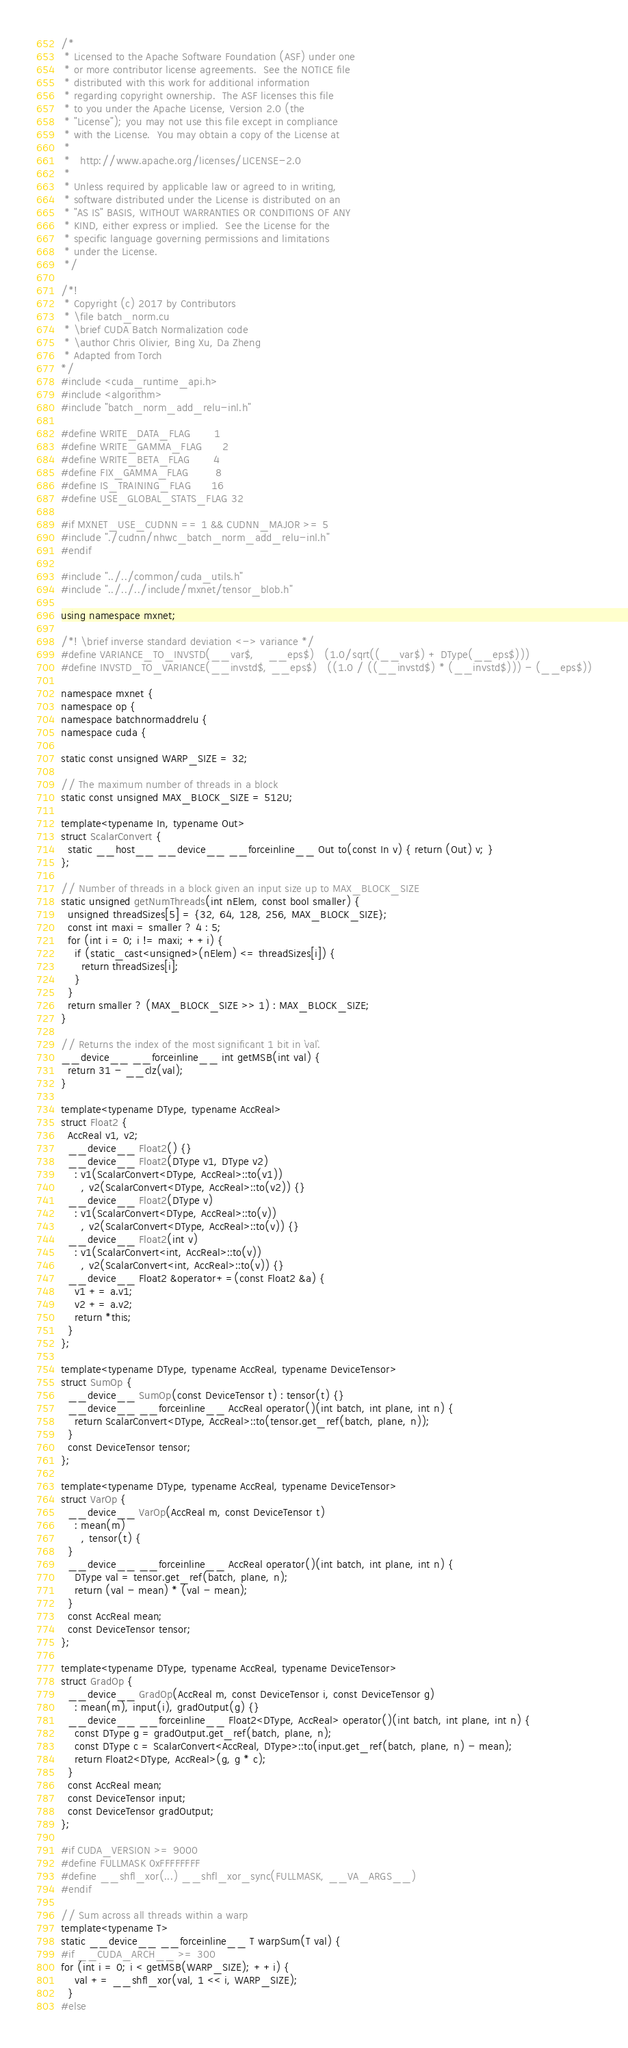<code> <loc_0><loc_0><loc_500><loc_500><_Cuda_>/*
 * Licensed to the Apache Software Foundation (ASF) under one
 * or more contributor license agreements.  See the NOTICE file
 * distributed with this work for additional information
 * regarding copyright ownership.  The ASF licenses this file
 * to you under the Apache License, Version 2.0 (the
 * "License"); you may not use this file except in compliance
 * with the License.  You may obtain a copy of the License at
 *
 *   http://www.apache.org/licenses/LICENSE-2.0
 *
 * Unless required by applicable law or agreed to in writing,
 * software distributed under the License is distributed on an
 * "AS IS" BASIS, WITHOUT WARRANTIES OR CONDITIONS OF ANY
 * KIND, either express or implied.  See the License for the
 * specific language governing permissions and limitations
 * under the License.
 */

/*!
 * Copyright (c) 2017 by Contributors
 * \file batch_norm.cu
 * \brief CUDA Batch Normalization code
 * \author Chris Olivier, Bing Xu, Da Zheng
 * Adapted from Torch
*/
#include <cuda_runtime_api.h>
#include <algorithm>
#include "batch_norm_add_relu-inl.h"

#define WRITE_DATA_FLAG       1
#define WRITE_GAMMA_FLAG      2
#define WRITE_BETA_FLAG       4
#define FIX_GAMMA_FLAG        8
#define IS_TRAINING_FLAG      16
#define USE_GLOBAL_STATS_FLAG 32

#if MXNET_USE_CUDNN == 1 && CUDNN_MAJOR >= 5
#include "./cudnn/nhwc_batch_norm_add_relu-inl.h"
#endif

#include "../../common/cuda_utils.h"
#include "../../../include/mxnet/tensor_blob.h"

using namespace mxnet;

/*! \brief inverse standard deviation <-> variance */
#define VARIANCE_TO_INVSTD(__var$,    __eps$)   (1.0/sqrt((__var$) + DType(__eps$)))
#define INVSTD_TO_VARIANCE(__invstd$, __eps$)   ((1.0 / ((__invstd$) * (__invstd$))) - (__eps$))

namespace mxnet {
namespace op {
namespace batchnormaddrelu {
namespace cuda {

static const unsigned WARP_SIZE = 32;

// The maximum number of threads in a block
static const unsigned MAX_BLOCK_SIZE = 512U;

template<typename In, typename Out>
struct ScalarConvert {
  static __host__ __device__ __forceinline__ Out to(const In v) { return (Out) v; }
};

// Number of threads in a block given an input size up to MAX_BLOCK_SIZE
static unsigned getNumThreads(int nElem, const bool smaller) {
  unsigned threadSizes[5] = {32, 64, 128, 256, MAX_BLOCK_SIZE};
  const int maxi = smaller ? 4 : 5;
  for (int i = 0; i != maxi; ++i) {
    if (static_cast<unsigned>(nElem) <= threadSizes[i]) {
      return threadSizes[i];
    }
  }
  return smaller ? (MAX_BLOCK_SIZE >> 1) : MAX_BLOCK_SIZE;
}

// Returns the index of the most significant 1 bit in `val`.
__device__ __forceinline__ int getMSB(int val) {
  return 31 - __clz(val);
}

template<typename DType, typename AccReal>
struct Float2 {
  AccReal v1, v2;
  __device__ Float2() {}
  __device__ Float2(DType v1, DType v2)
    : v1(ScalarConvert<DType, AccReal>::to(v1))
      , v2(ScalarConvert<DType, AccReal>::to(v2)) {}
  __device__ Float2(DType v)
    : v1(ScalarConvert<DType, AccReal>::to(v))
      , v2(ScalarConvert<DType, AccReal>::to(v)) {}
  __device__ Float2(int v)
    : v1(ScalarConvert<int, AccReal>::to(v))
      , v2(ScalarConvert<int, AccReal>::to(v)) {}
  __device__ Float2 &operator+=(const Float2 &a) {
    v1 += a.v1;
    v2 += a.v2;
    return *this;
  }
};

template<typename DType, typename AccReal, typename DeviceTensor>
struct SumOp {
  __device__ SumOp(const DeviceTensor t) : tensor(t) {}
  __device__ __forceinline__ AccReal operator()(int batch, int plane, int n) {
    return ScalarConvert<DType, AccReal>::to(tensor.get_ref(batch, plane, n));
  }
  const DeviceTensor tensor;
};

template<typename DType, typename AccReal, typename DeviceTensor>
struct VarOp {
  __device__ VarOp(AccReal m, const DeviceTensor t)
    : mean(m)
      , tensor(t) {
  }
  __device__ __forceinline__ AccReal operator()(int batch, int plane, int n) {
    DType val = tensor.get_ref(batch, plane, n);
    return (val - mean) * (val - mean);
  }
  const AccReal mean;
  const DeviceTensor tensor;
};

template<typename DType, typename AccReal, typename DeviceTensor>
struct GradOp {
  __device__ GradOp(AccReal m, const DeviceTensor i, const DeviceTensor g)
    : mean(m), input(i), gradOutput(g) {}
  __device__ __forceinline__ Float2<DType, AccReal> operator()(int batch, int plane, int n) {
    const DType g = gradOutput.get_ref(batch, plane, n);
    const DType c = ScalarConvert<AccReal, DType>::to(input.get_ref(batch, plane, n) - mean);
    return Float2<DType, AccReal>(g, g * c);
  }
  const AccReal mean;
  const DeviceTensor input;
  const DeviceTensor gradOutput;
};

#if CUDA_VERSION >= 9000
#define FULLMASK 0xFFFFFFFF
#define __shfl_xor(...) __shfl_xor_sync(FULLMASK, __VA_ARGS__)
#endif

// Sum across all threads within a warp
template<typename T>
static __device__ __forceinline__ T warpSum(T val) {
#if __CUDA_ARCH__ >= 300
for (int i = 0; i < getMSB(WARP_SIZE); ++i) {
    val += __shfl_xor(val, 1 << i, WARP_SIZE);
  }
#else</code> 